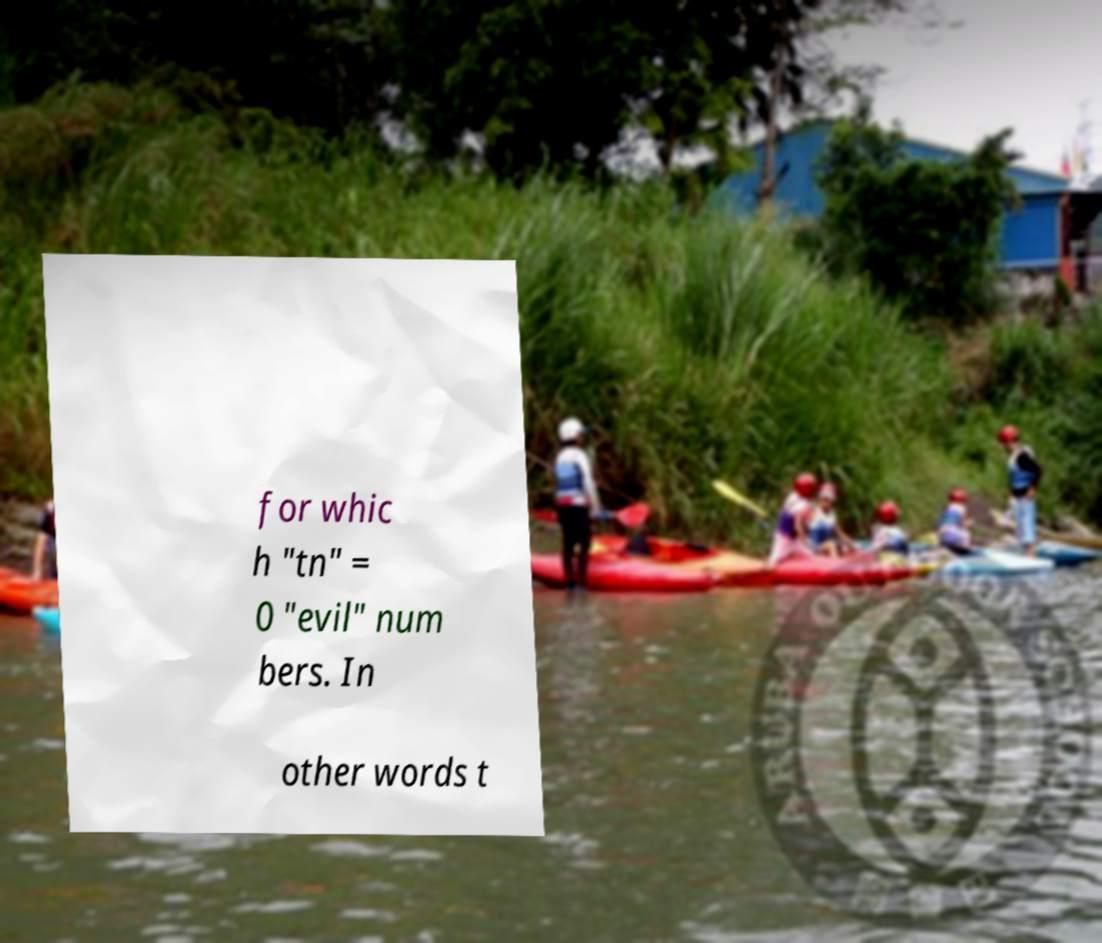Could you extract and type out the text from this image? for whic h "tn" = 0 "evil" num bers. In other words t 